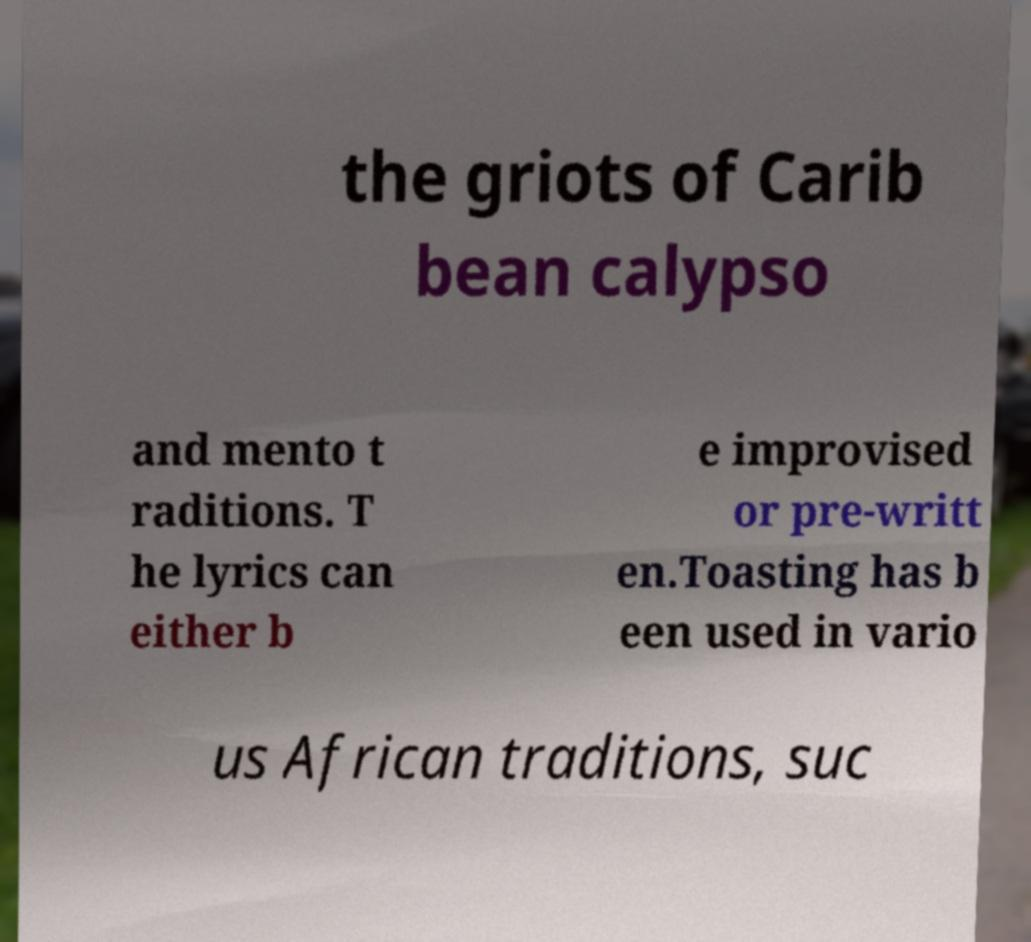Can you read and provide the text displayed in the image?This photo seems to have some interesting text. Can you extract and type it out for me? the griots of Carib bean calypso and mento t raditions. T he lyrics can either b e improvised or pre-writt en.Toasting has b een used in vario us African traditions, suc 